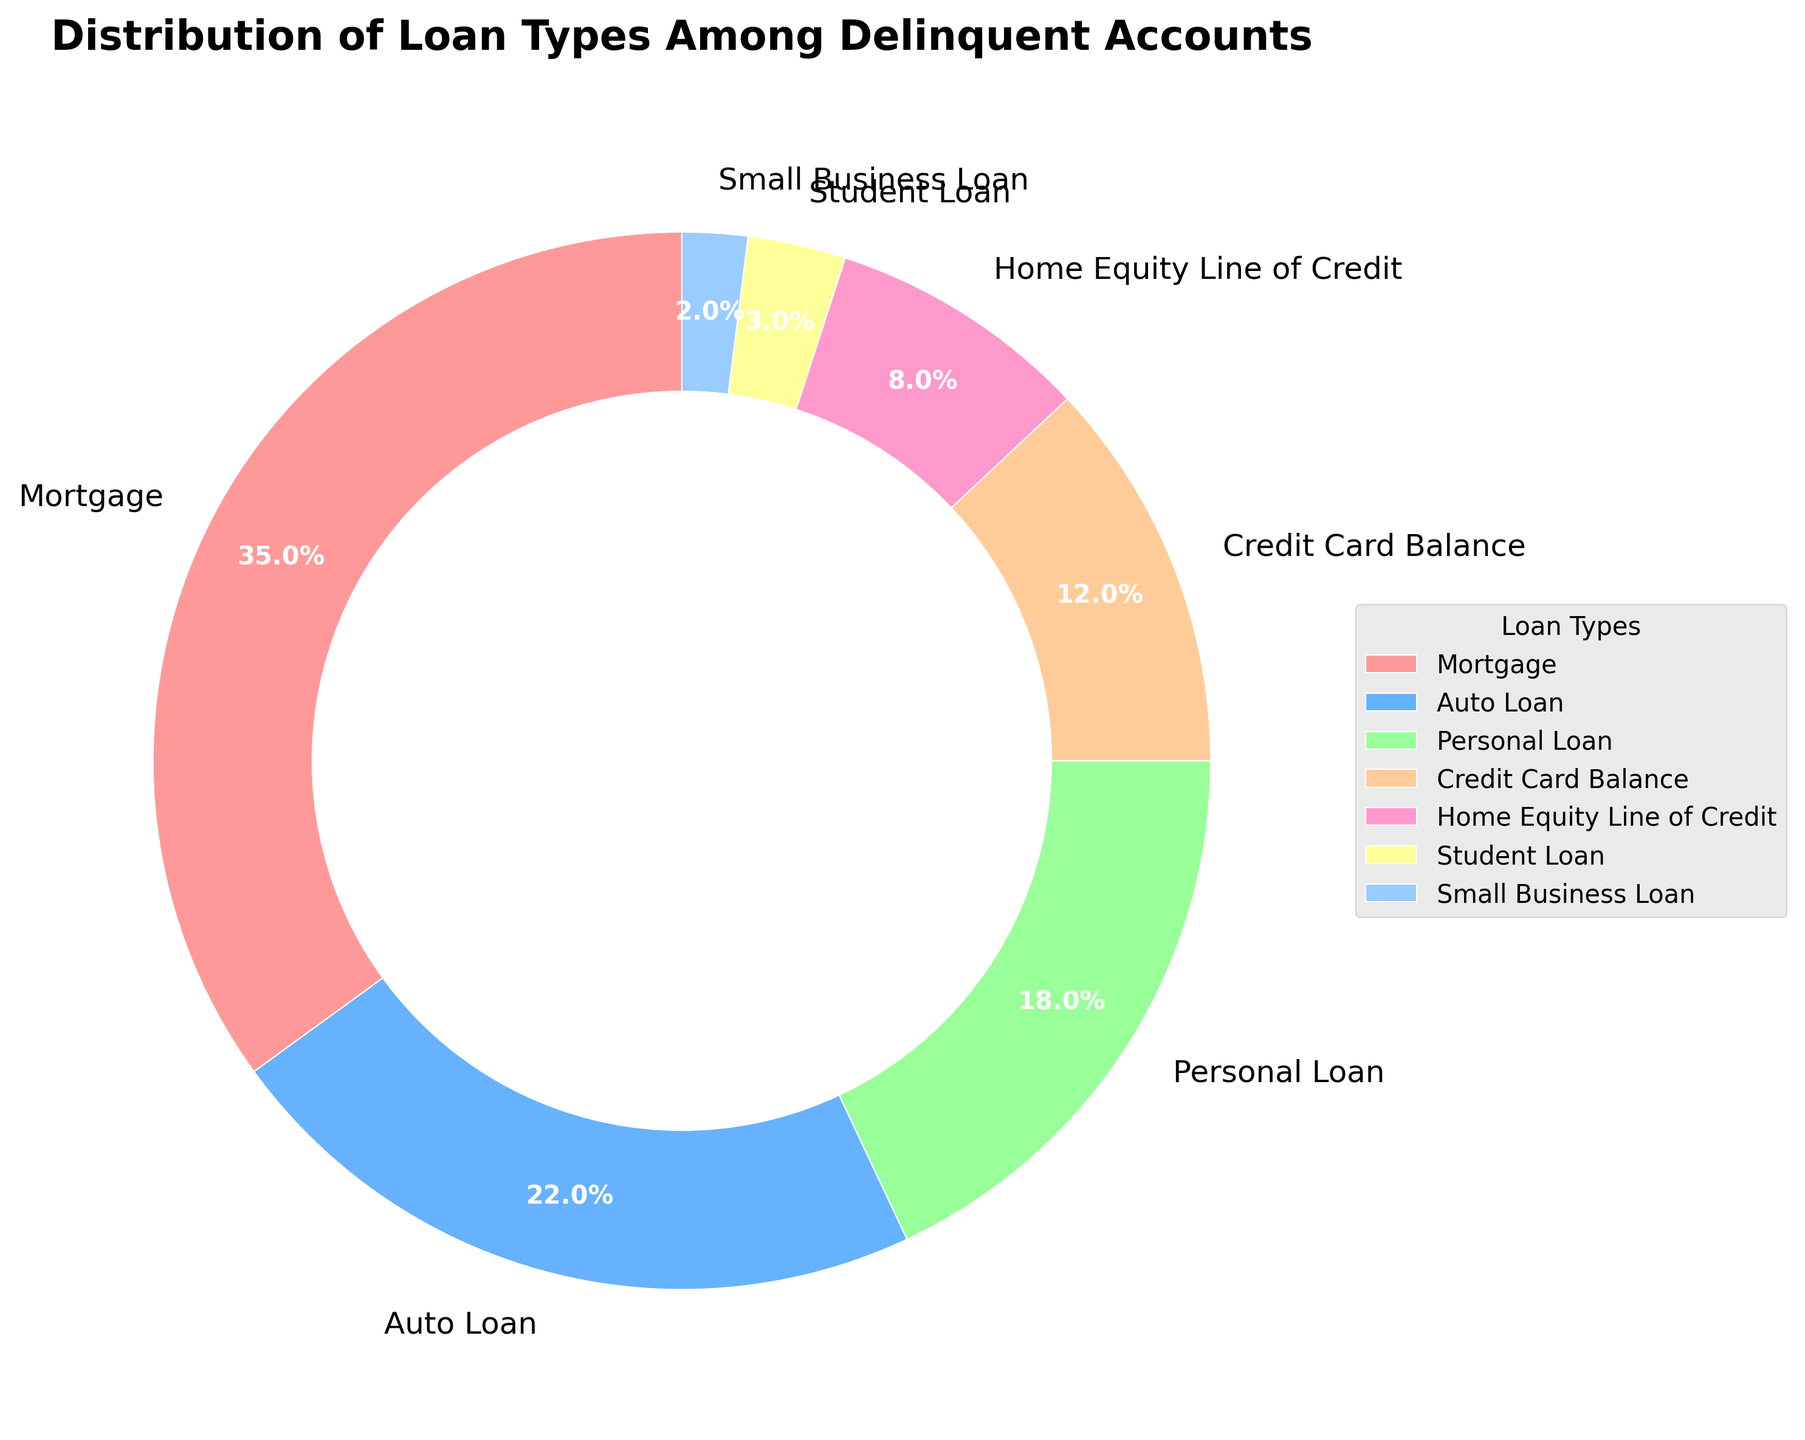What percentage of delinquent accounts are due to mortgage loans? The pie chart segment representing mortgage loans is labeled and shows the percentage.
Answer: 35% Which loan type has the smallest proportion of delinquent accounts? The smallest segment in the pie chart is labeled with the loan type and its percentage.
Answer: Small Business Loan What is the combined percentage of delinquent accounts for Personal Loan and Credit Card Balance? Sum the percentages of Personal Loan (18%) and Credit Card Balance (12%) shown in the chart. 18% + 12% = 30%
Answer: 30% Are there more delinquent accounts for Auto Loans or Home Equity Line of Credit? Compare the two segments labeled Auto Loan (22%) and Home Equity Line of Credit (8%).
Answer: Auto Loan List the loan types that have a percentage of delinquent accounts greater than 15%. Identify the segments with percentages greater than 15%: Mortgage (35%), Auto Loan (22%), Personal Loan (18%).
Answer: Mortgage, Auto Loan, Personal Loan Which color represents the segment for Credit Card Balance? Identify the specific color associated with the Credit Card Balance segment in the chart.
Answer: Orange-like (specific shades not provided, but visually identified as different from others) How much larger is the percentage of Mortgage delinquent accounts compared to Student Loan delinquent accounts? Subtract the percentage for Student Loan (3%) from Mortgage (35%). 35% - 3% = 32%
Answer: 32% Do Personal Loan and Home Equity Line of Credit combined have a higher percentage than Mortgage delinquent accounts? Compare the sum of Personal Loan (18%) and Home Equity Line of Credit (8%), which is 26%, with Mortgage (35%). 26% < 35%
Answer: No What is the second highest loan type by percentage in delinquent accounts? Identify the segment with the second largest percentage after Mortgage (35%), which is Auto Loan (22%).
Answer: Auto Loan What is the sum of percentages for delinquent accounts comprising Auto Loan, Student Loan, and Small Business Loan? Add the percentages of Auto Loan (22%), Student Loan (3%), and Small Business Loan (2%). 22% + 3% + 2% = 27%
Answer: 27% 